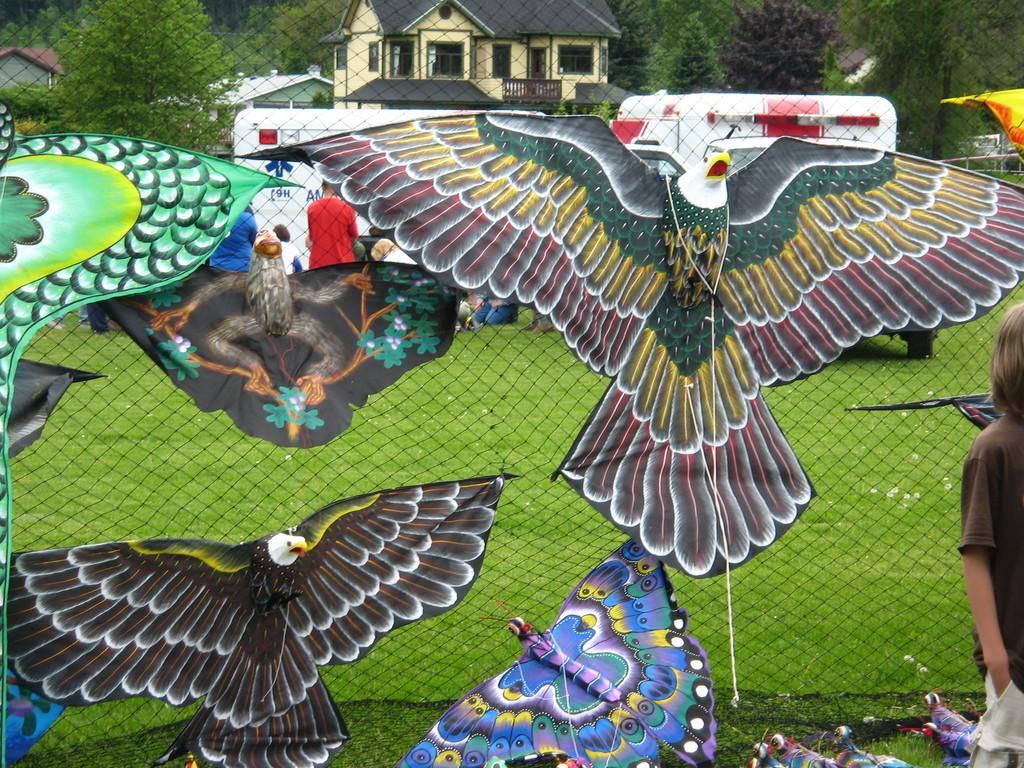Describe this image in one or two sentences. In this picture there is a kid standing and we can see kites and mesh, through mesh we can see grass, people, vehicles, houses and trees. 